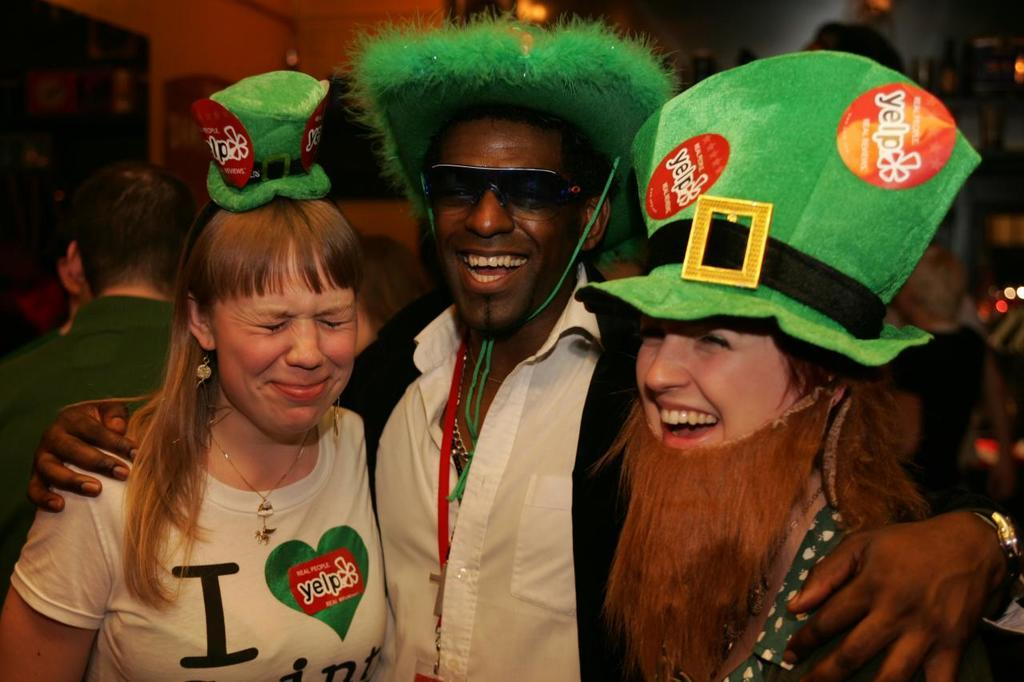How many people are in the image? There are two women and a man in the image, making a total of three people. What are the individuals wearing? The individuals are wearing hats. Can you describe the background of the image? The background is blurred, and there are people visible in the background. What type of liquid can be seen dripping from the swing in the image? There is no swing present in the image, so there is no liquid dripping from it. 